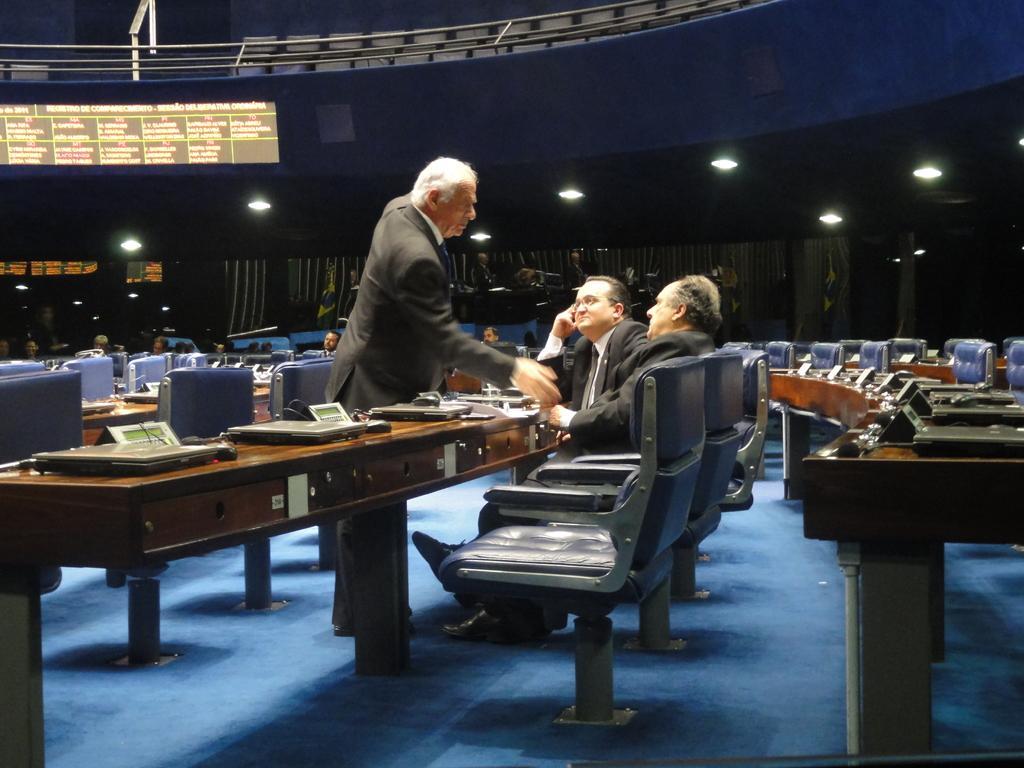Describe this image in one or two sentences. In this image there are three persons two of them are sitting and one is standing in between them there is a table on which there are laptops and at the background of the image there are also persons sitting on the chair. 